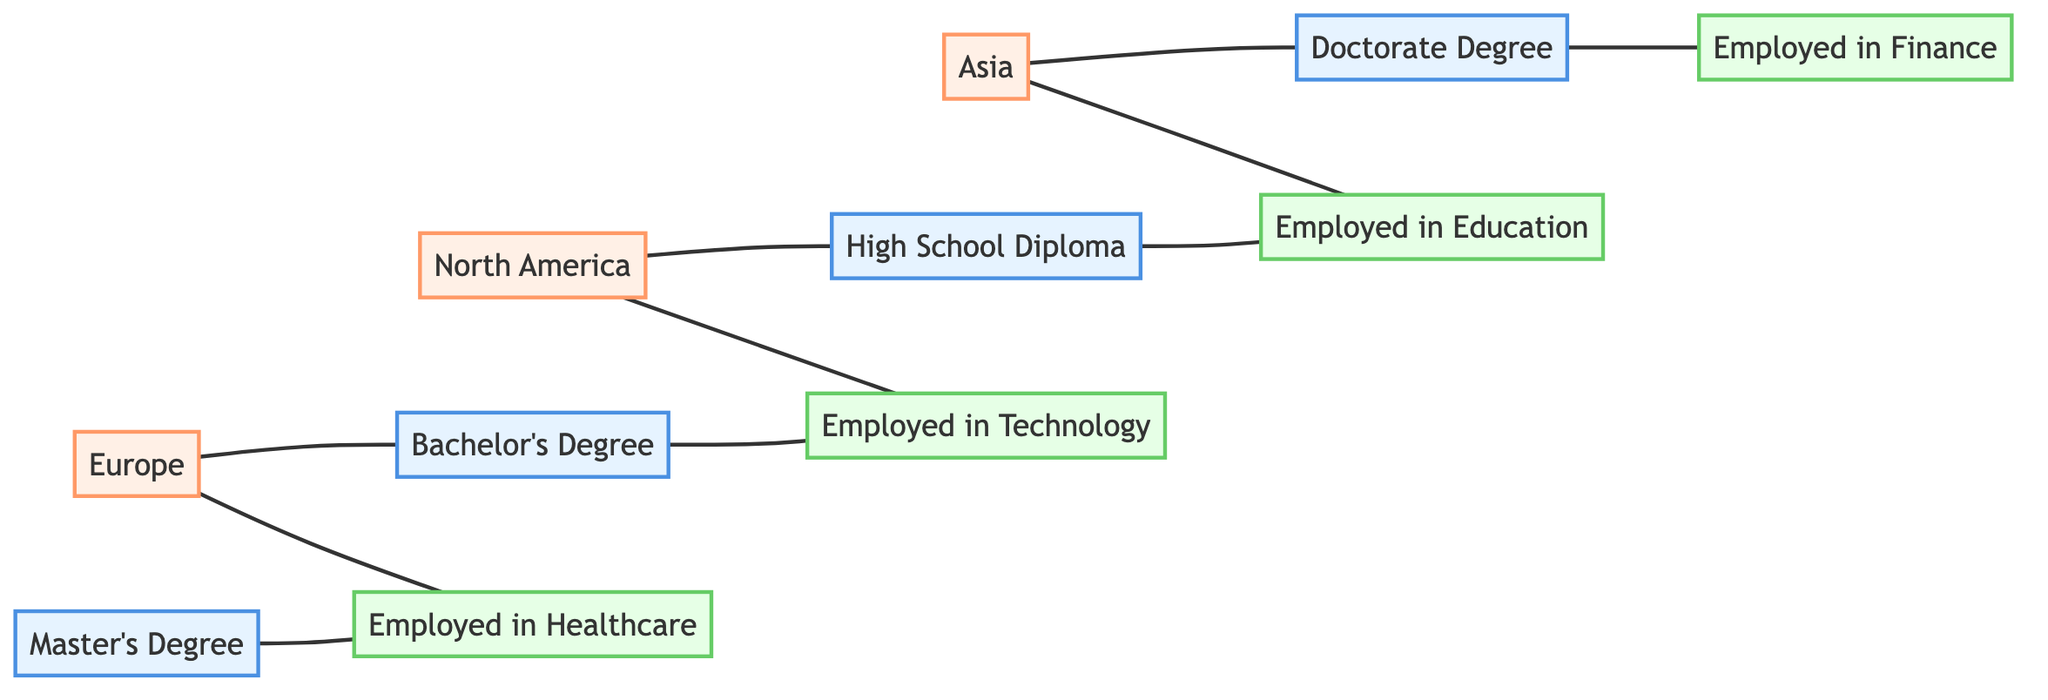What are the education levels represented in the diagram? The diagram lists four education levels represented by the nodes: High School Diploma, Bachelor's Degree, Master's Degree, and Doctorate Degree.
Answer: High School Diploma, Bachelor's Degree, Master's Degree, Doctorate Degree Which employment type is connected to the Bachelor's Degree? The Bachelor's Degree node has an edge leading to the "Employed in Technology" node. This indicates that the employment type associated with a Bachelor's Degree is in Technology.
Answer: Employed in Technology How many regions are shown in the diagram? The diagram includes three regions: North America, Europe, and Asia. This can be confirmed by counting the region nodes connected to different employment and education nodes.
Answer: 3 Which education level is linked to employment in Healthcare? Only the Master's Degree node has an edge that connects to the "Employed in Healthcare" node, which shows that those with a Master's Degree are connected to this employment type.
Answer: Master's Degree Which region is associated with both High School Diploma and Employment in Technology? North America is the region connected to both the "High School Diploma" node and the "Employed in Technology" node, indicating that both are relevant to this region.
Answer: North America What is the relationship between Doctorate Degree and Employment in Finance? The Doctorate Degree node connects directly to the "Employed in Finance" node, indicating that those with a Doctorate Degree have employment in Finance.
Answer: Employed in Finance What is the total number of edges in the diagram? By counting the relationships (edges) between the nodes, there are twelve edges in total, which link both education and employment nodes as well as region nodes.
Answer: 12 Which region is connected to the employment type in Education? Asia is the region that connects to the "Employed in Education" node according to the edges shown in the diagram.
Answer: Asia 